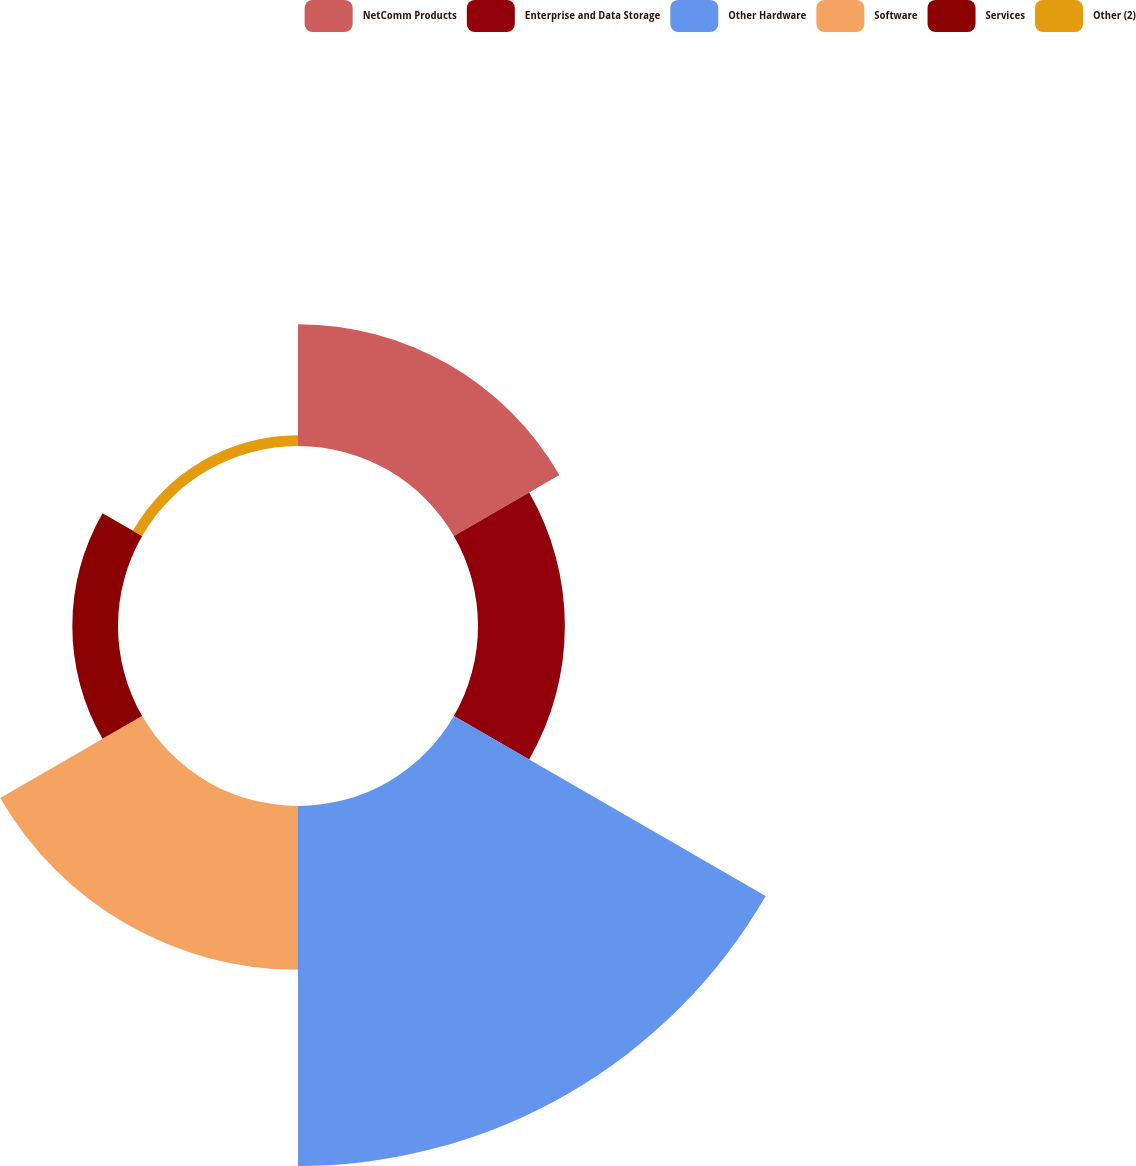<chart> <loc_0><loc_0><loc_500><loc_500><pie_chart><fcel>NetComm Products<fcel>Enterprise and Data Storage<fcel>Other Hardware<fcel>Software<fcel>Services<fcel>Other (2)<nl><fcel>15.44%<fcel>11.01%<fcel>45.63%<fcel>20.77%<fcel>5.79%<fcel>1.36%<nl></chart> 